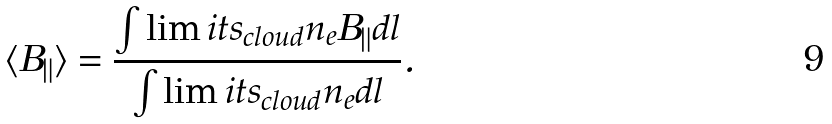Convert formula to latex. <formula><loc_0><loc_0><loc_500><loc_500>\langle B _ { \| } \rangle = \frac { { \int \lim i t s _ { c l o u d } { n _ { e } B _ { \| } d l } } } { { \int \lim i t s _ { c l o u d } { n _ { e } d l } } } .</formula> 